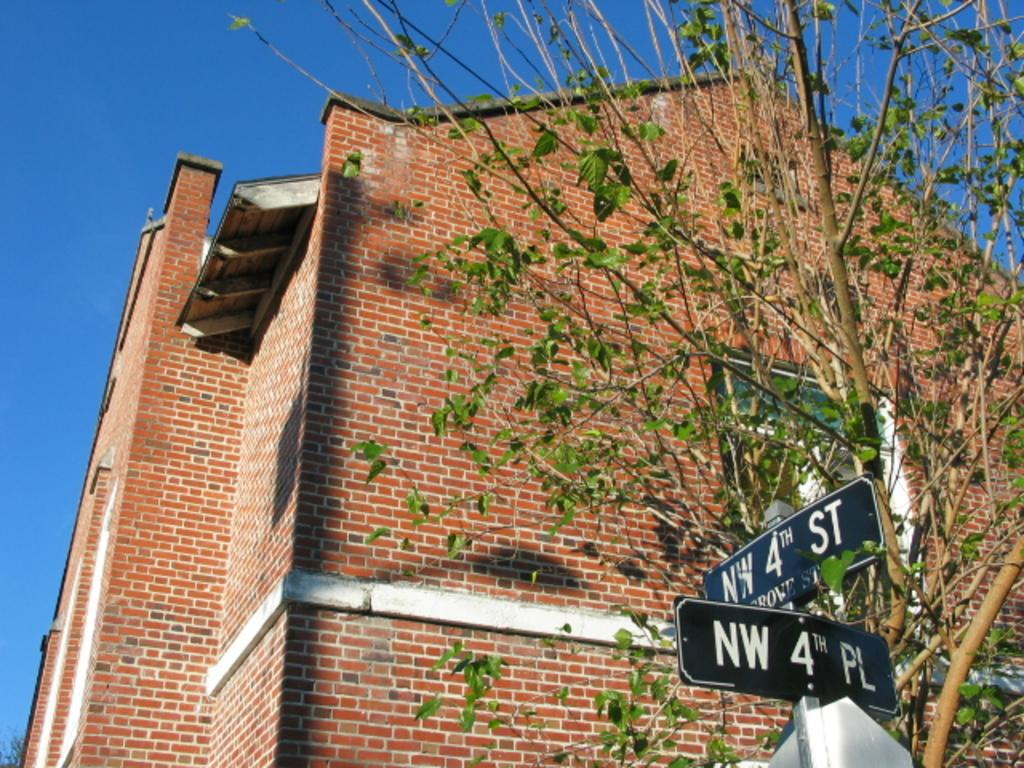<image>
Write a terse but informative summary of the picture. A building behind a sign states NW 4th Street and NW 4th Place 